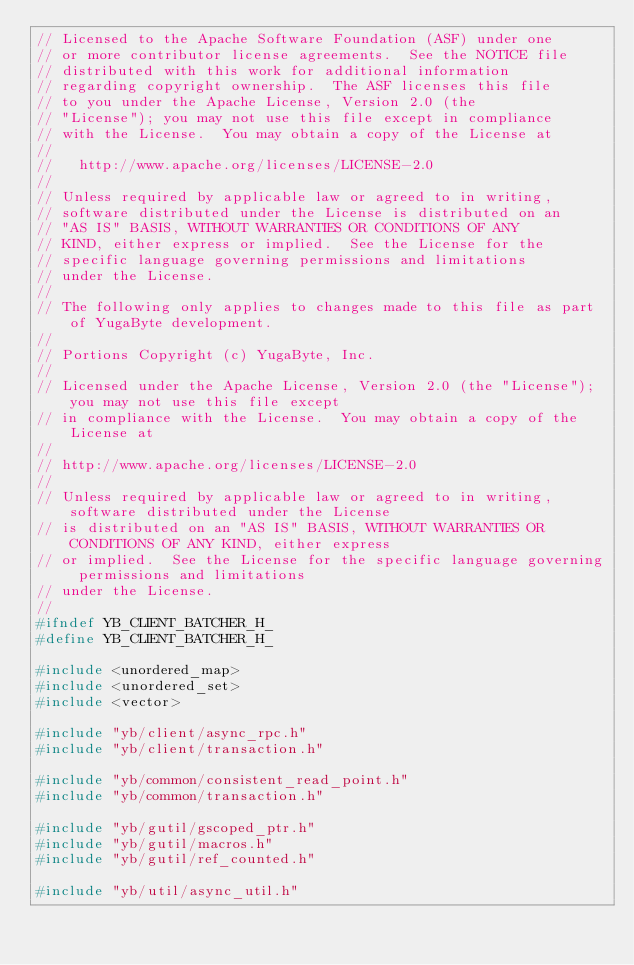Convert code to text. <code><loc_0><loc_0><loc_500><loc_500><_C_>// Licensed to the Apache Software Foundation (ASF) under one
// or more contributor license agreements.  See the NOTICE file
// distributed with this work for additional information
// regarding copyright ownership.  The ASF licenses this file
// to you under the Apache License, Version 2.0 (the
// "License"); you may not use this file except in compliance
// with the License.  You may obtain a copy of the License at
//
//   http://www.apache.org/licenses/LICENSE-2.0
//
// Unless required by applicable law or agreed to in writing,
// software distributed under the License is distributed on an
// "AS IS" BASIS, WITHOUT WARRANTIES OR CONDITIONS OF ANY
// KIND, either express or implied.  See the License for the
// specific language governing permissions and limitations
// under the License.
//
// The following only applies to changes made to this file as part of YugaByte development.
//
// Portions Copyright (c) YugaByte, Inc.
//
// Licensed under the Apache License, Version 2.0 (the "License"); you may not use this file except
// in compliance with the License.  You may obtain a copy of the License at
//
// http://www.apache.org/licenses/LICENSE-2.0
//
// Unless required by applicable law or agreed to in writing, software distributed under the License
// is distributed on an "AS IS" BASIS, WITHOUT WARRANTIES OR CONDITIONS OF ANY KIND, either express
// or implied.  See the License for the specific language governing permissions and limitations
// under the License.
//
#ifndef YB_CLIENT_BATCHER_H_
#define YB_CLIENT_BATCHER_H_

#include <unordered_map>
#include <unordered_set>
#include <vector>

#include "yb/client/async_rpc.h"
#include "yb/client/transaction.h"

#include "yb/common/consistent_read_point.h"
#include "yb/common/transaction.h"

#include "yb/gutil/gscoped_ptr.h"
#include "yb/gutil/macros.h"
#include "yb/gutil/ref_counted.h"

#include "yb/util/async_util.h"</code> 